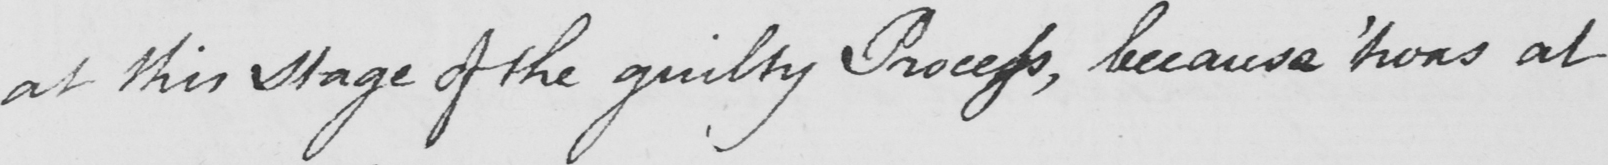What text is written in this handwritten line? at this stage of the guilty Process , because  ' twas at 